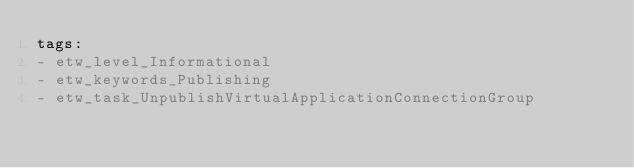<code> <loc_0><loc_0><loc_500><loc_500><_YAML_>tags:
- etw_level_Informational
- etw_keywords_Publishing
- etw_task_UnpublishVirtualApplicationConnectionGroup
</code> 